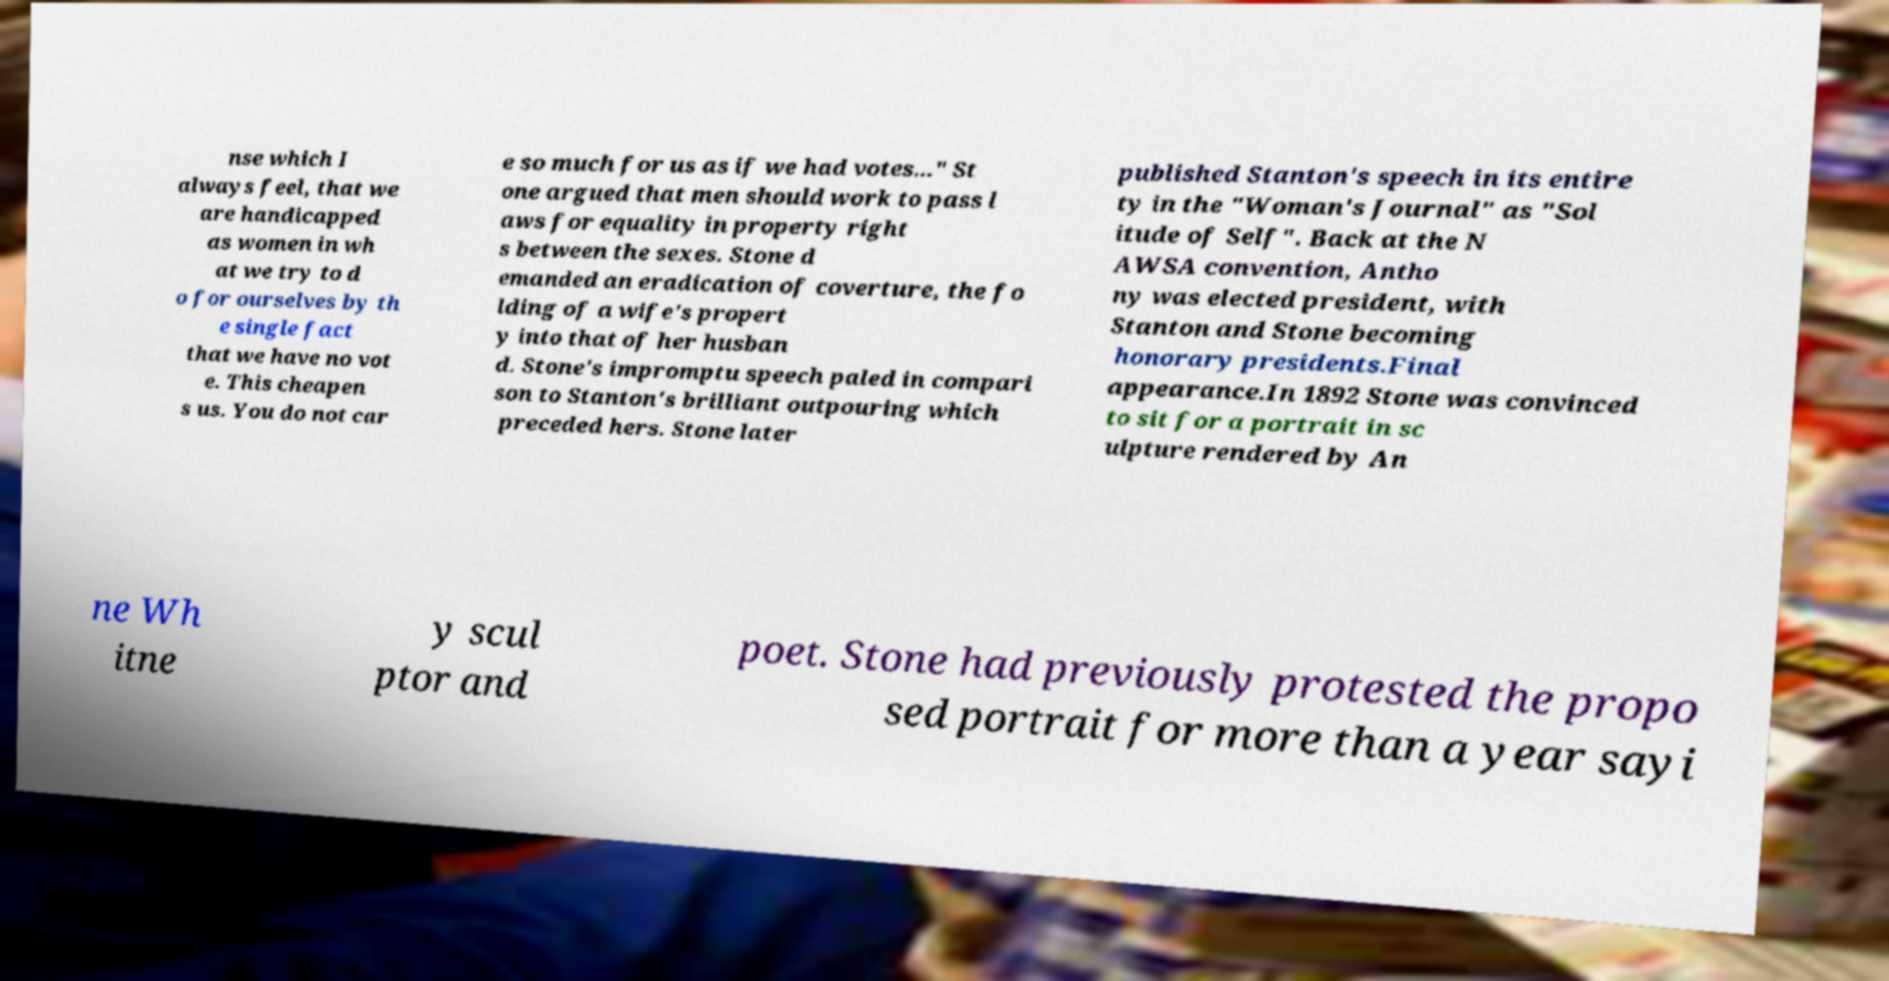Please identify and transcribe the text found in this image. nse which I always feel, that we are handicapped as women in wh at we try to d o for ourselves by th e single fact that we have no vot e. This cheapen s us. You do not car e so much for us as if we had votes..." St one argued that men should work to pass l aws for equality in property right s between the sexes. Stone d emanded an eradication of coverture, the fo lding of a wife's propert y into that of her husban d. Stone's impromptu speech paled in compari son to Stanton's brilliant outpouring which preceded hers. Stone later published Stanton's speech in its entire ty in the "Woman's Journal" as "Sol itude of Self". Back at the N AWSA convention, Antho ny was elected president, with Stanton and Stone becoming honorary presidents.Final appearance.In 1892 Stone was convinced to sit for a portrait in sc ulpture rendered by An ne Wh itne y scul ptor and poet. Stone had previously protested the propo sed portrait for more than a year sayi 